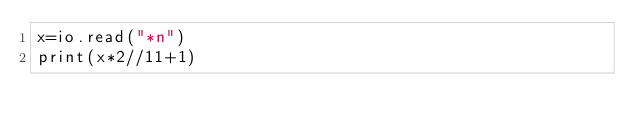Convert code to text. <code><loc_0><loc_0><loc_500><loc_500><_Lua_>x=io.read("*n")
print(x*2//11+1)</code> 